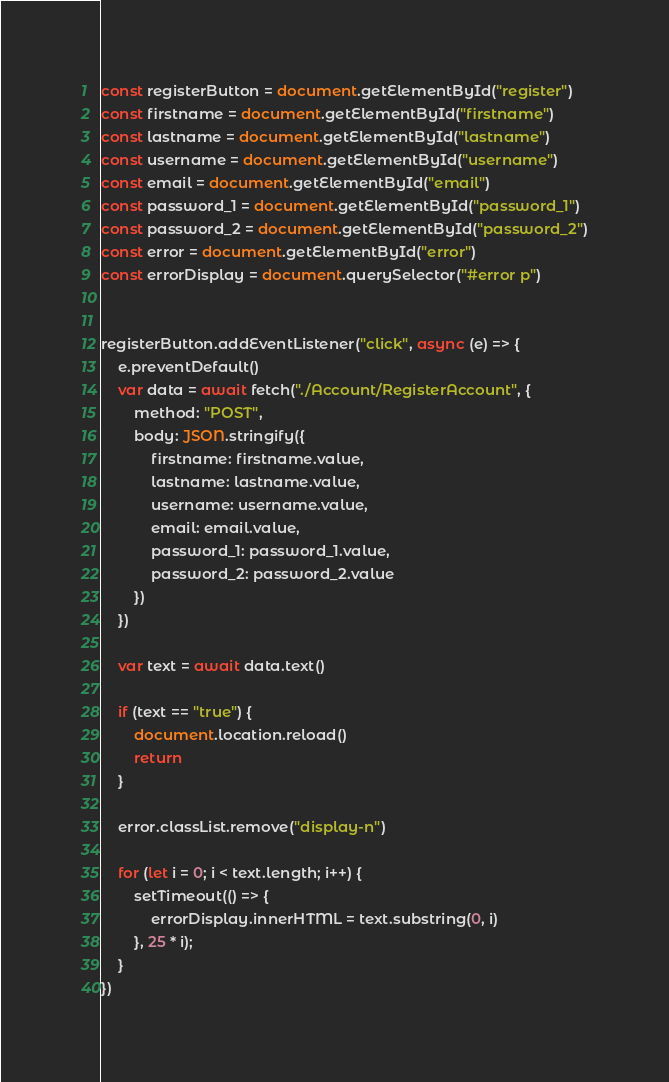Convert code to text. <code><loc_0><loc_0><loc_500><loc_500><_JavaScript_>const registerButton = document.getElementById("register")
const firstname = document.getElementById("firstname")
const lastname = document.getElementById("lastname")
const username = document.getElementById("username")
const email = document.getElementById("email")
const password_1 = document.getElementById("password_1")
const password_2 = document.getElementById("password_2")
const error = document.getElementById("error")
const errorDisplay = document.querySelector("#error p")


registerButton.addEventListener("click", async (e) => {
    e.preventDefault()
    var data = await fetch("./Account/RegisterAccount", {
        method: "POST",
        body: JSON.stringify({
            firstname: firstname.value,
            lastname: lastname.value,
            username: username.value,
            email: email.value,
            password_1: password_1.value,
            password_2: password_2.value
        })
    })

    var text = await data.text()

    if (text == "true") {
        document.location.reload()
        return
    }

    error.classList.remove("display-n")

    for (let i = 0; i < text.length; i++) {
        setTimeout(() => {
            errorDisplay.innerHTML = text.substring(0, i)
        }, 25 * i);
    }
})</code> 